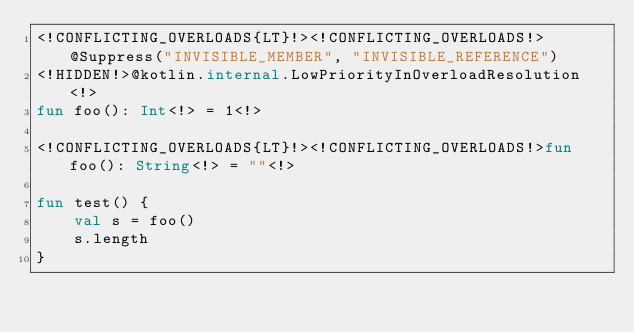Convert code to text. <code><loc_0><loc_0><loc_500><loc_500><_Kotlin_><!CONFLICTING_OVERLOADS{LT}!><!CONFLICTING_OVERLOADS!>@Suppress("INVISIBLE_MEMBER", "INVISIBLE_REFERENCE")
<!HIDDEN!>@kotlin.internal.LowPriorityInOverloadResolution<!>
fun foo(): Int<!> = 1<!>

<!CONFLICTING_OVERLOADS{LT}!><!CONFLICTING_OVERLOADS!>fun foo(): String<!> = ""<!>

fun test() {
    val s = foo()
    s.length
}
</code> 